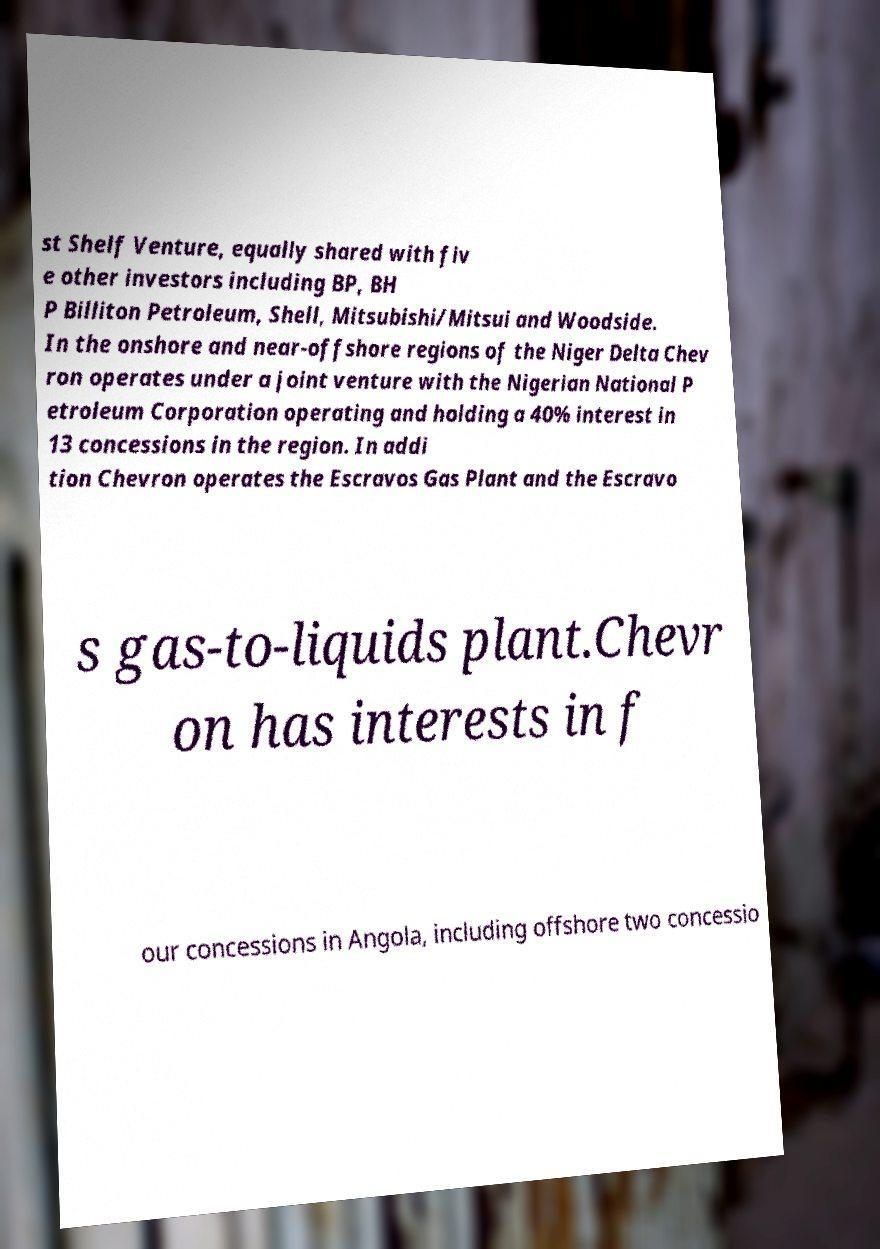Can you read and provide the text displayed in the image?This photo seems to have some interesting text. Can you extract and type it out for me? st Shelf Venture, equally shared with fiv e other investors including BP, BH P Billiton Petroleum, Shell, Mitsubishi/Mitsui and Woodside. In the onshore and near-offshore regions of the Niger Delta Chev ron operates under a joint venture with the Nigerian National P etroleum Corporation operating and holding a 40% interest in 13 concessions in the region. In addi tion Chevron operates the Escravos Gas Plant and the Escravo s gas-to-liquids plant.Chevr on has interests in f our concessions in Angola, including offshore two concessio 